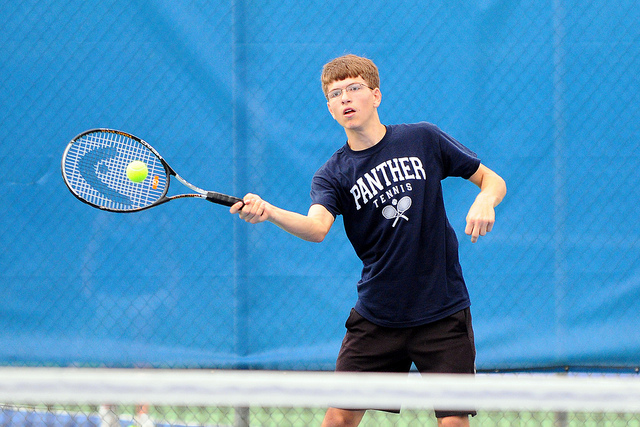Identify the text contained in this image. PANTHER TENNIS 